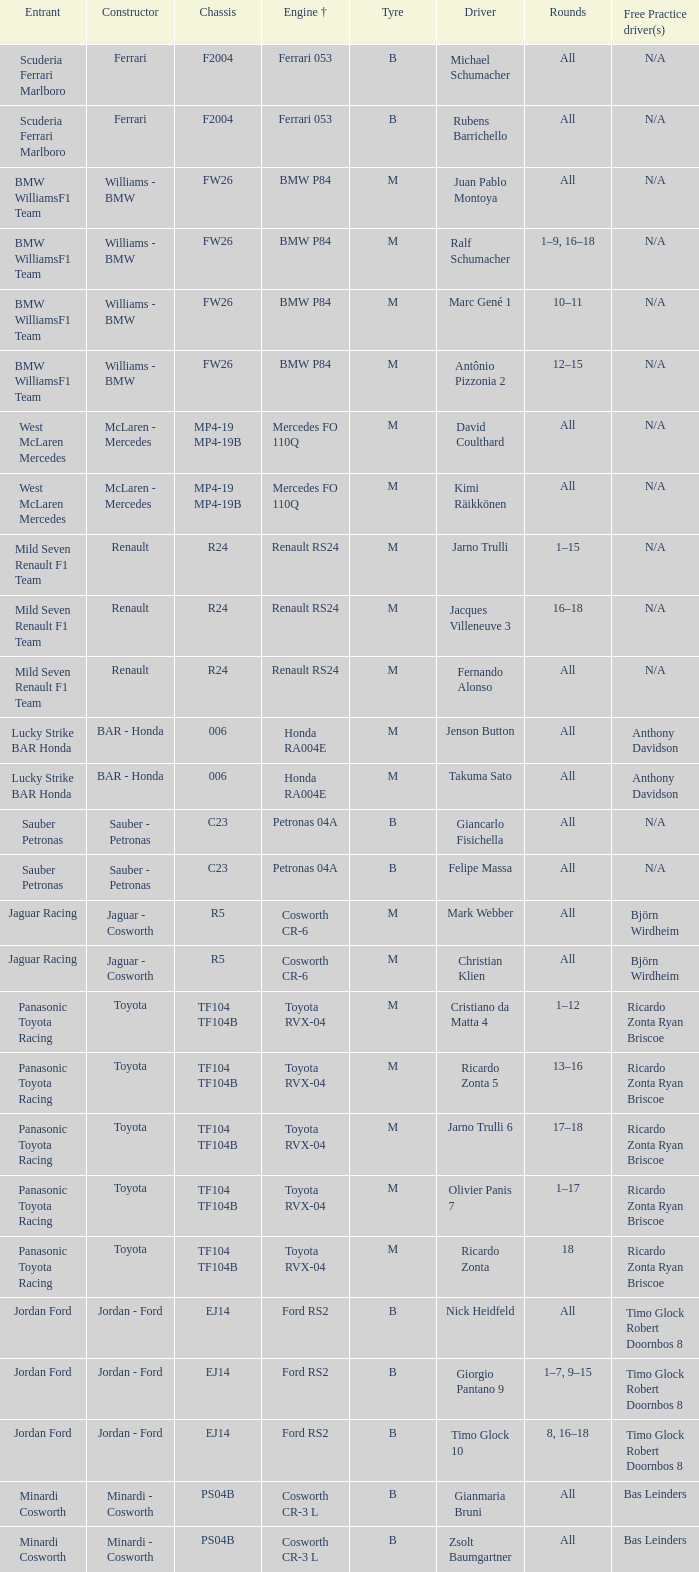What are some free practice possibilities for using a ford rs2 engine+? Timo Glock Robert Doornbos 8, Timo Glock Robert Doornbos 8, Timo Glock Robert Doornbos 8. 